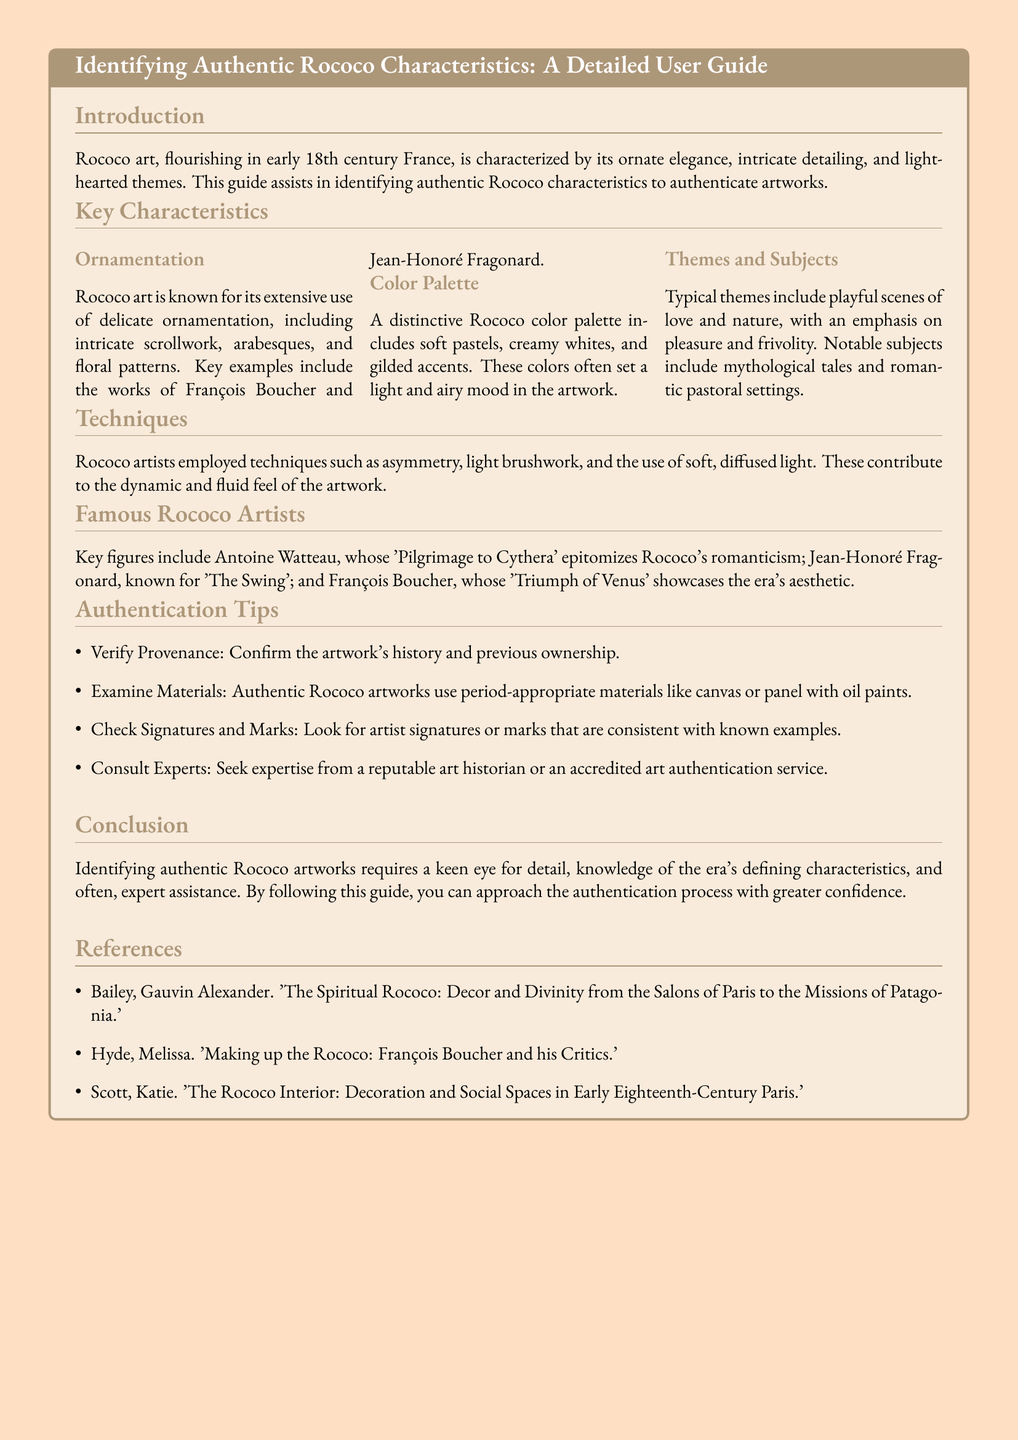What are the key themes in Rococo art? The key themes in Rococo art include playful scenes of love and nature, emphasizing pleasure and frivolity.
Answer: Playful scenes of love and nature Who is the artist known for 'The Swing'? The document states that Jean-Honoré Fragonard is known for 'The Swing'.
Answer: Jean-Honoré Fragonard What colors are predominantly used in Rococo art? The predominant colors in Rococo art include soft pastels, creamy whites, and gilded accents.
Answer: Soft pastels, creamy whites, gilded accents How many famous Rococo artists are mentioned in the guide? The guide mentions three famous Rococo artists.
Answer: Three What should be verified to authenticate a Rococo artwork? The provenance of the artwork should be verified for authentication.
Answer: Provenance What is the characteristic technique associated with Rococo artists? A characteristic technique associated with Rococo artists is the use of asymmetry.
Answer: Asymmetry What does the introduction highlight about Rococo art? The introduction highlights that Rococo art is characterized by ornate elegance and intricate detailing.
Answer: Ornate elegance, intricate detailing How should one check for authenticity according to the guide? One should check for artist signatures or marks that are consistent with known examples.
Answer: Artist signatures or marks 